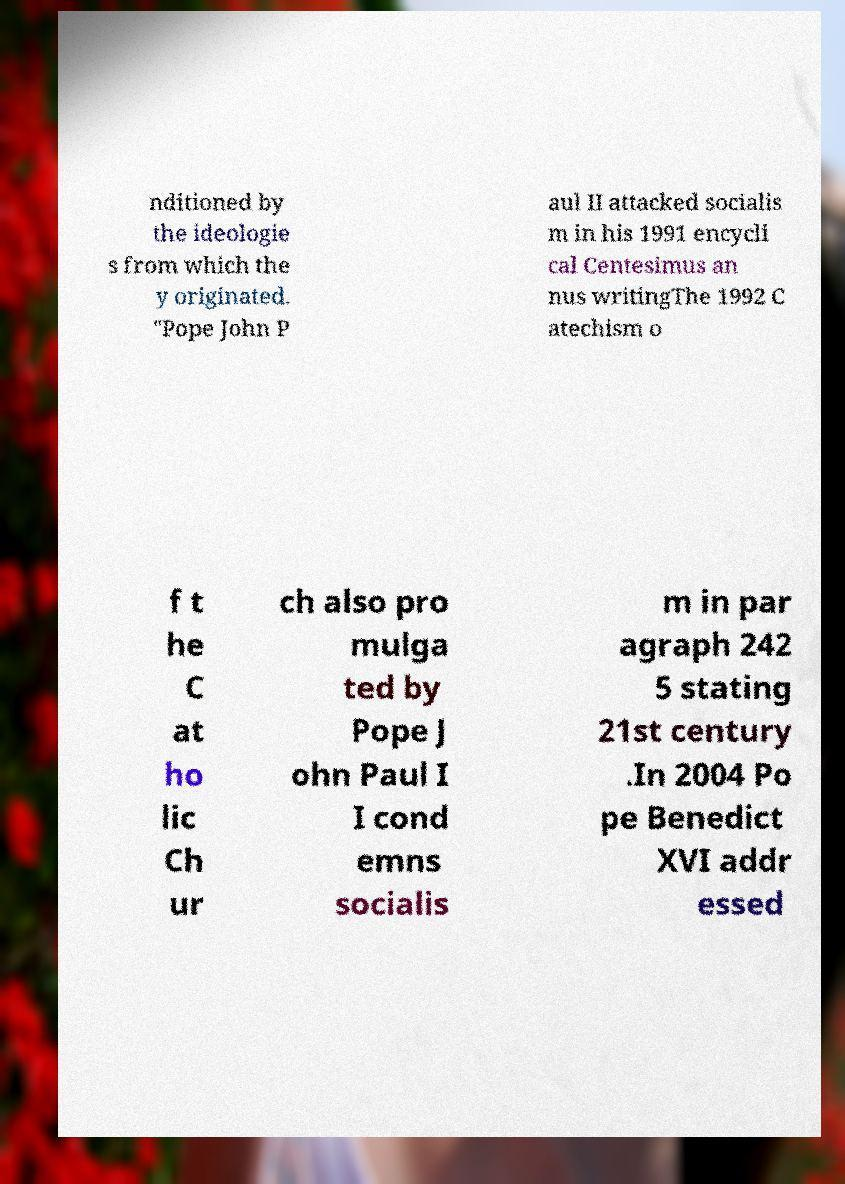Can you read and provide the text displayed in the image?This photo seems to have some interesting text. Can you extract and type it out for me? nditioned by the ideologie s from which the y originated. "Pope John P aul II attacked socialis m in his 1991 encycli cal Centesimus an nus writingThe 1992 C atechism o f t he C at ho lic Ch ur ch also pro mulga ted by Pope J ohn Paul I I cond emns socialis m in par agraph 242 5 stating 21st century .In 2004 Po pe Benedict XVI addr essed 